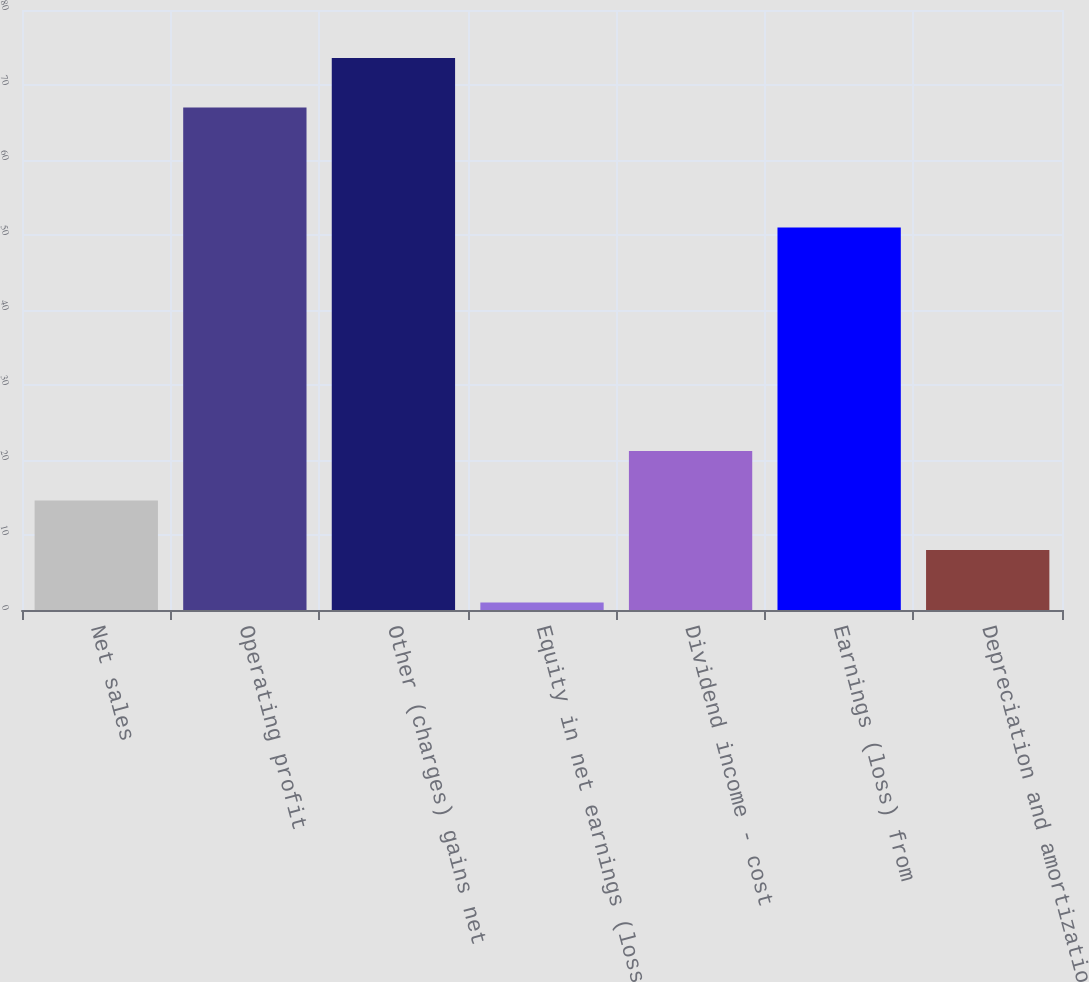Convert chart. <chart><loc_0><loc_0><loc_500><loc_500><bar_chart><fcel>Net sales<fcel>Operating profit<fcel>Other (charges) gains net<fcel>Equity in net earnings (loss)<fcel>Dividend income - cost<fcel>Earnings (loss) from<fcel>Depreciation and amortization<nl><fcel>14.6<fcel>67<fcel>73.6<fcel>1<fcel>21.2<fcel>51<fcel>8<nl></chart> 